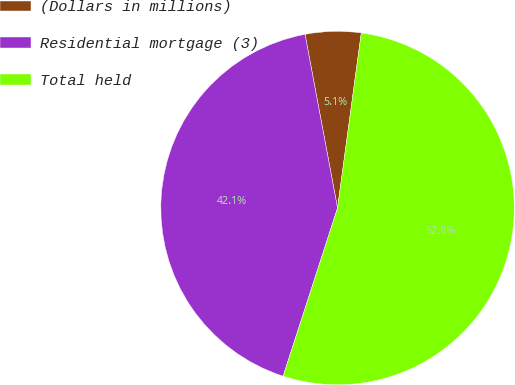Convert chart to OTSL. <chart><loc_0><loc_0><loc_500><loc_500><pie_chart><fcel>(Dollars in millions)<fcel>Residential mortgage (3)<fcel>Total held<nl><fcel>5.09%<fcel>42.07%<fcel>52.83%<nl></chart> 